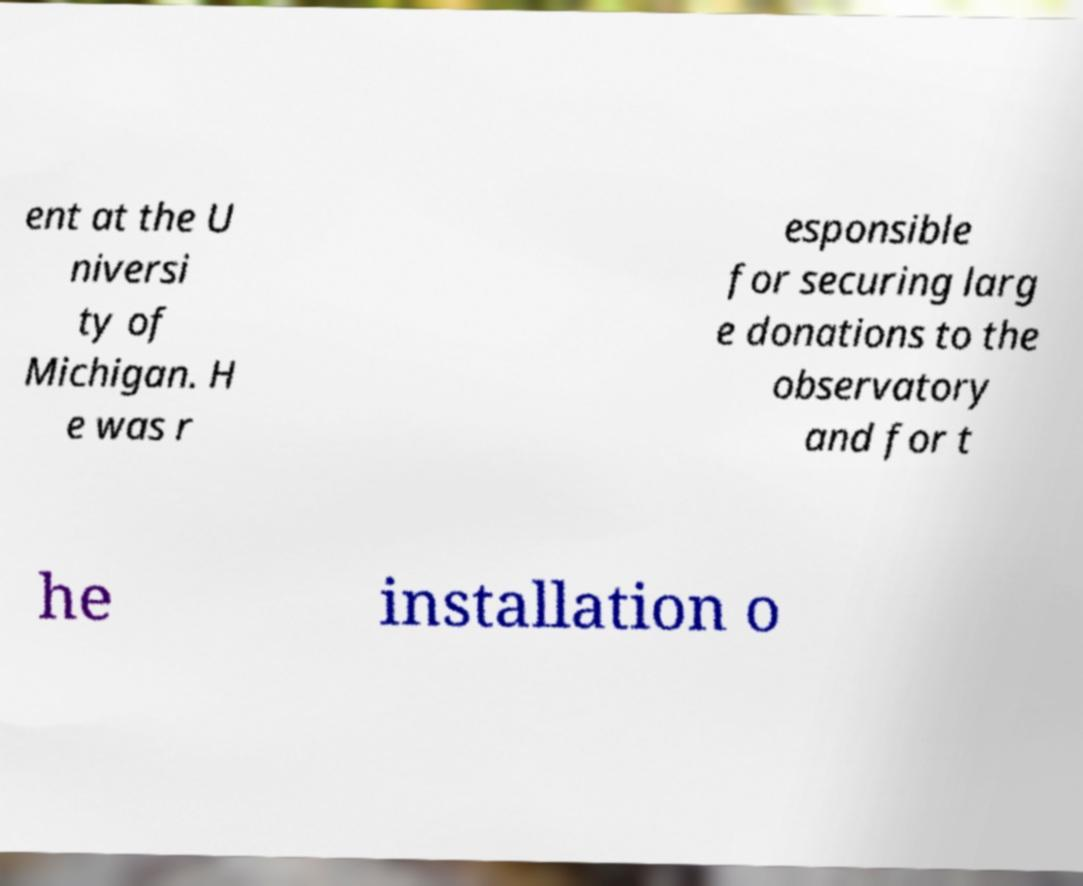Can you read and provide the text displayed in the image?This photo seems to have some interesting text. Can you extract and type it out for me? ent at the U niversi ty of Michigan. H e was r esponsible for securing larg e donations to the observatory and for t he installation o 